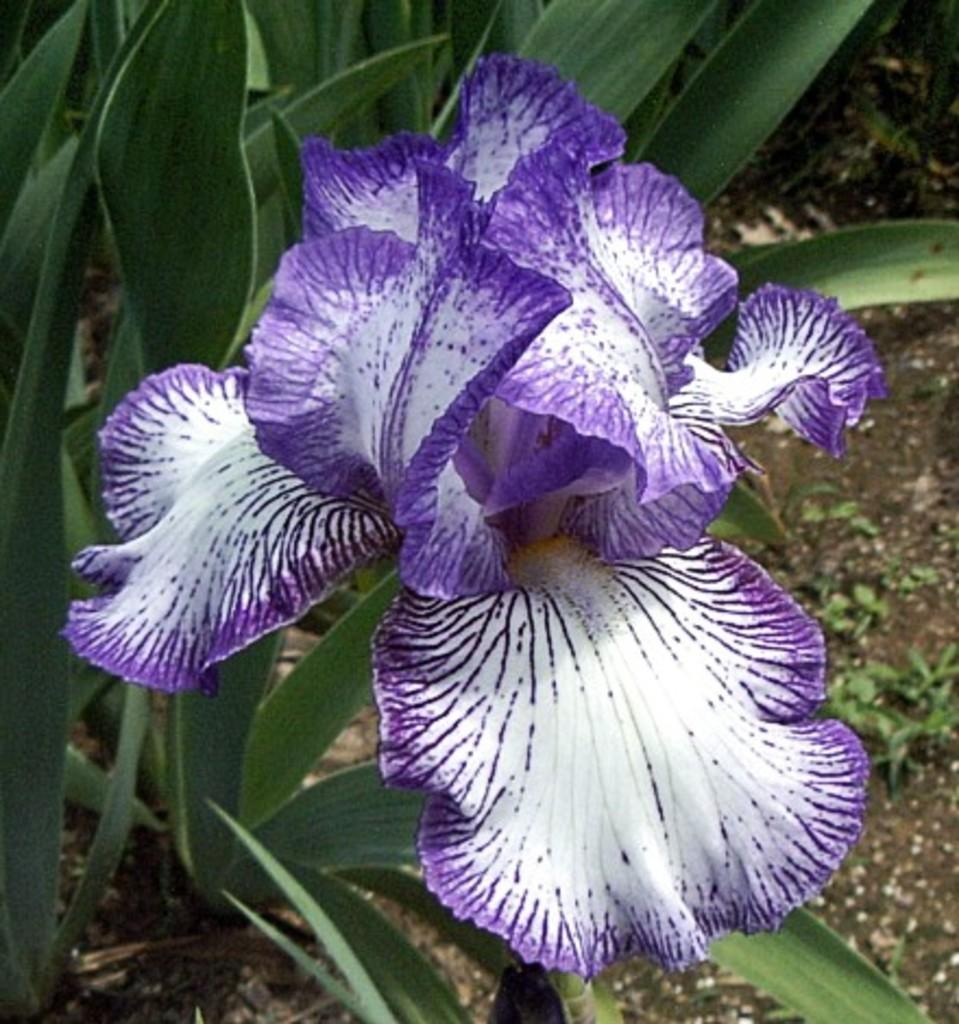What type of living organism is present in the image? There is a plant in the image. What specific feature of the plant is mentioned in the facts? The plant has flowers. What colors are the petals of the flowers? The petals of the flowers are in violet and white colors. What can be seen on the right side of the image? The ground is visible on the right side of the image. How many family members are visible in the image? There are no family members present in the image; it features a plant with flowers. Can you tell me how many frogs are hopping around the plant in the image? There are no frogs present in the image; it features a plant with flowers. 